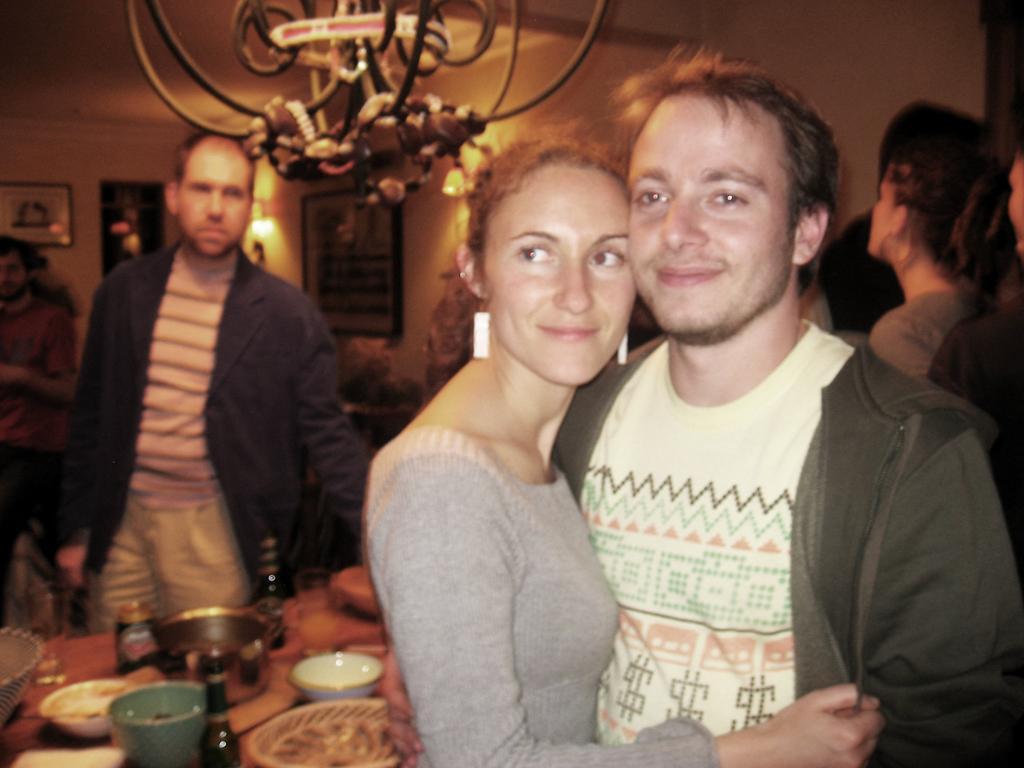In one or two sentences, can you explain what this image depicts? In this picture I can see there is a man standing and he is wearing a coat, is a woman standing beside him, both are smiling and there is a table beside them and there are few utensils placed on it. There are a few people standing in the backdrop and there is a man standing behind the table and there are few photo frames arranged on the wall and there is a light attached to the ceiling. 